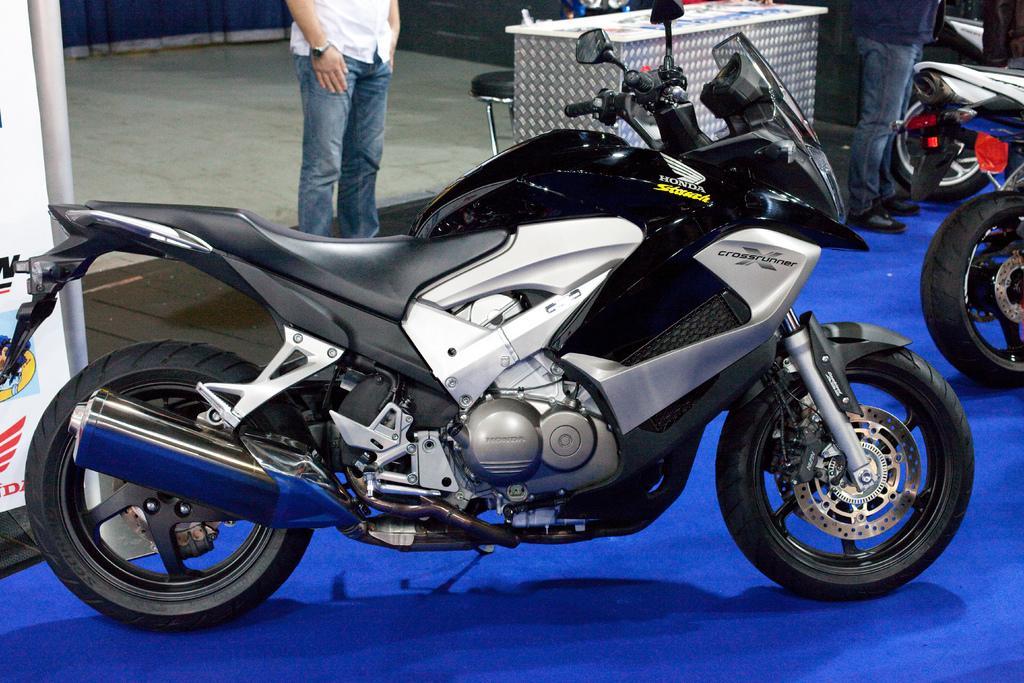In one or two sentences, can you explain what this image depicts? We can see bikes on the blue surface. There are people standing. We can see objects on the table,chair,board and floor. 